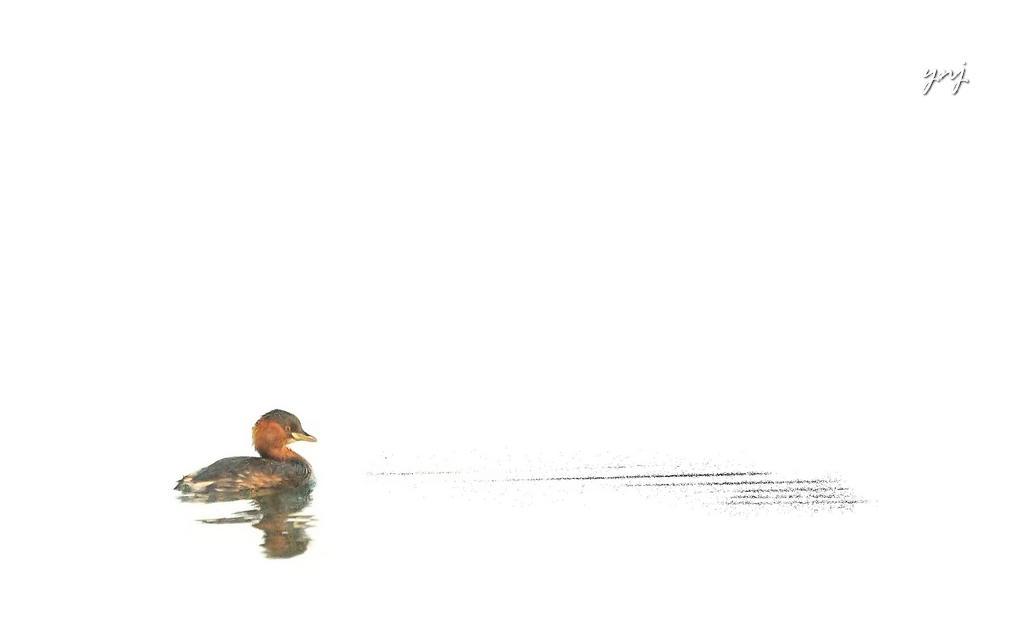How would you summarize this image in a sentence or two? In this picture I can observe sketch of a duck on the left side. In the top right side I can observe text. The background is in white color. 